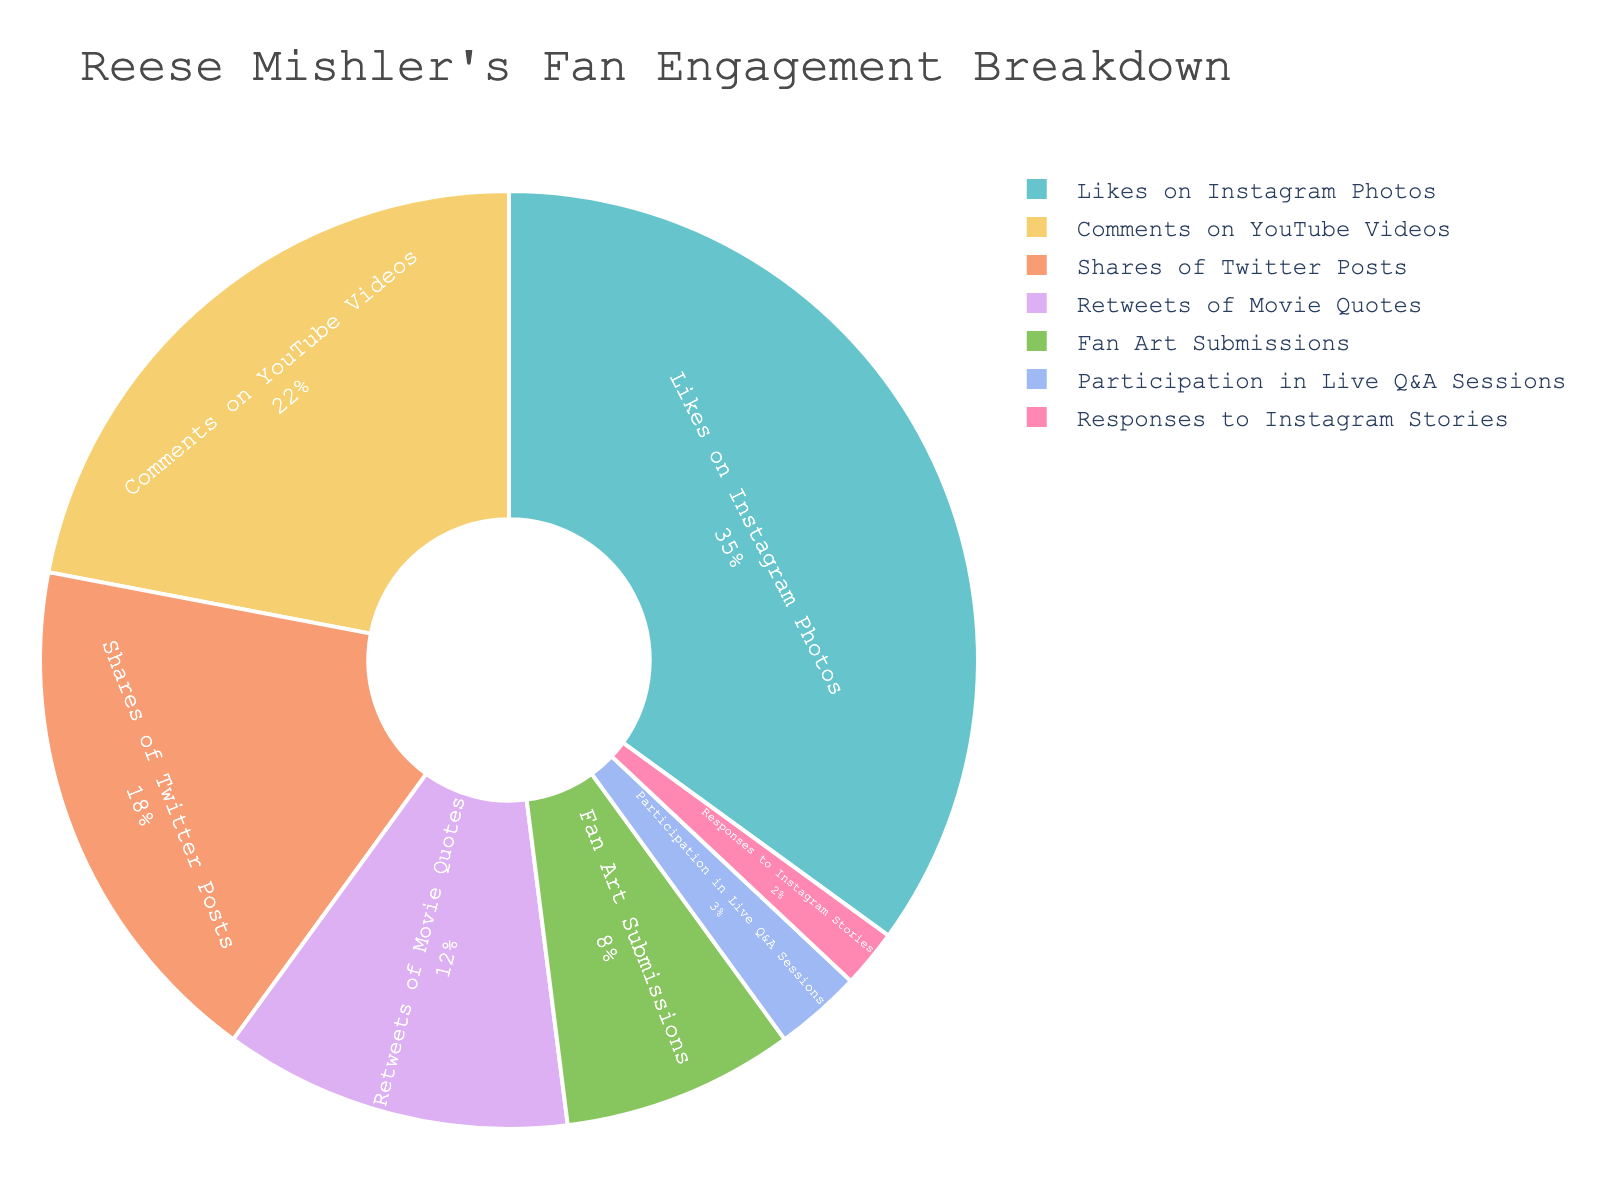Which type of engagement has the highest percentage? By looking at the pie chart, the segment representing 'Likes on Instagram Photos' occupies the largest portion of the chart.
Answer: Likes on Instagram Photos What is the combined percentage of 'Fan Art Submissions' and 'Participation in Live Q&A Sessions'? 'Fan Art Submissions' have a percentage of 8% and 'Participation in Live Q&A Sessions' have a percentage of 3%. Adding these together: 8 + 3 = 11%
Answer: 11% Which type of engagement has a higher percentage, 'Comments on YouTube Videos' or 'Shares of Twitter Posts'? By examining the chart, 'Comments on YouTube Videos' has a percentage of 22%, while 'Shares of Twitter Posts' has a percentage of 18%. 22% is greater than 18%.
Answer: Comments on YouTube Videos How much more engagement in percentage does 'Likes on Instagram Photos' have compared to 'Retweets of Movie Quotes'? 'Likes on Instagram Photos' occupy 35% and 'Retweets of Movie Quotes' 12%. The difference is 35 - 12 = 23%
Answer: 23% What is the percentage of engagement for 'Responses to Instagram Stories'? According to the chart, 'Responses to Instagram Stories' occupies the smallest segment, which is labeled as 2%.
Answer: 2% Is the percentage of engagement for 'Shares of Twitter Posts' closer to 'Comments on YouTube Videos' or 'Retweets of Movie Quotes'? 'Shares of Twitter Posts' have a percentage of 18%. 'Comments on YouTube Videos' have 22% (difference of 4) and 'Retweets of Movie Quotes' have 12% (difference of 6). 4 is closer to 18.
Answer: Comments on YouTube Videos What is the combined percentage of 'Likes on Instagram Photos', 'Comments on YouTube Videos', and 'Shares of Twitter Posts'? The respective percentages are 35%, 22%, and 18%. Adding these together: 35 + 22 + 18 = 75%
Answer: 75% What is the median engagement percentage for all engagement types? List the percentages: 35%, 22%, 18%, 12%, 8%, 3%, 2%. Arrange them in ascending order: 2%, 3%, 8%, 12%, 18%, 22%, 35%. The median is the middle value, which is 12%.
Answer: 12% Which engagement type appears to be represented by the lightest color? The pie chart uses a qualitative Pastel color palette, and based on common visual weight in such palettes, lighter colors are often used for smaller values. 'Responses to Instagram Stories' at 2% appears in the lightest segment visually.
Answer: Responses to Instagram Stories How does the percentage of 'Participation in Live Q&A Sessions' compare to 'Retweets of Movie Quotes' in terms of scale? 'Participation in Live Q&A Sessions' is 3% and 'Retweets of Movie Quotes' is 12%. Dividing 12 by 3 shows that 'Retweets of Movie Quotes' engagement is 4 times that of 'Participation in Live Q&A Sessions'.
Answer: 4 times 